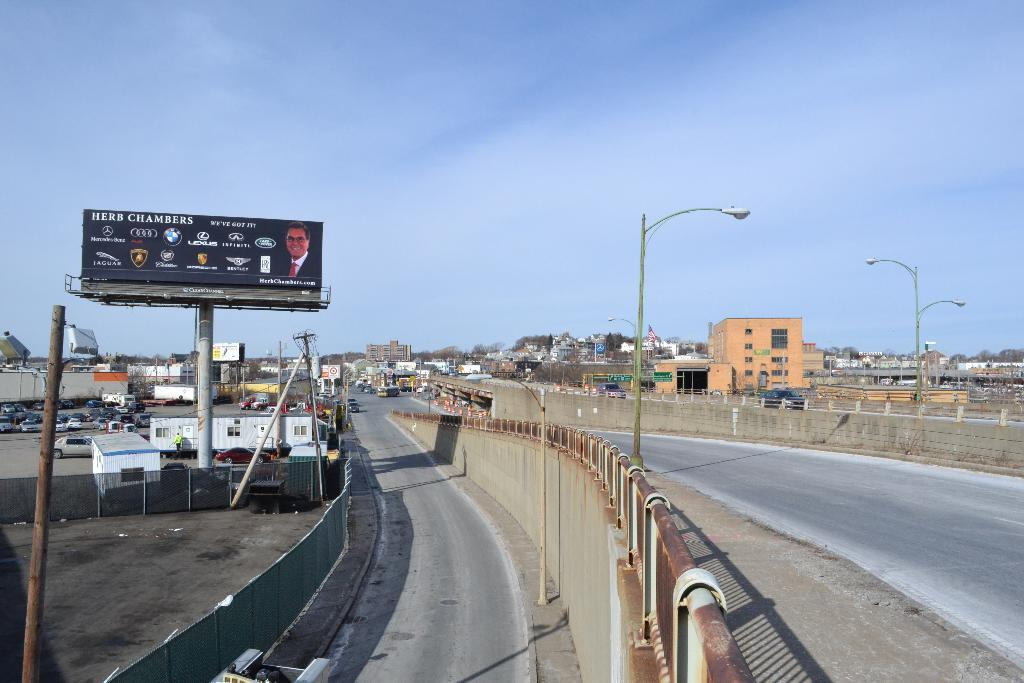<image>
Present a compact description of the photo's key features. A highway service road with a billboard for Herb Chambers' car dealership. 